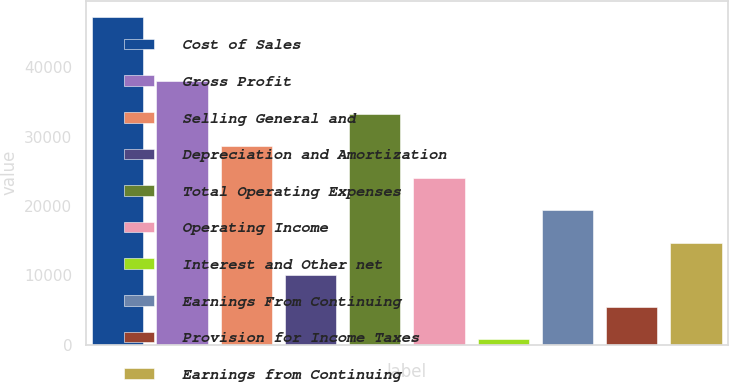<chart> <loc_0><loc_0><loc_500><loc_500><bar_chart><fcel>Cost of Sales<fcel>Gross Profit<fcel>Selling General and<fcel>Depreciation and Amortization<fcel>Total Operating Expenses<fcel>Operating Income<fcel>Interest and Other net<fcel>Earnings From Continuing<fcel>Provision for Income Taxes<fcel>Earnings from Continuing<nl><fcel>47298<fcel>37992.2<fcel>28686.4<fcel>10074.8<fcel>33339.3<fcel>24033.5<fcel>769<fcel>19380.6<fcel>5421.9<fcel>14727.7<nl></chart> 